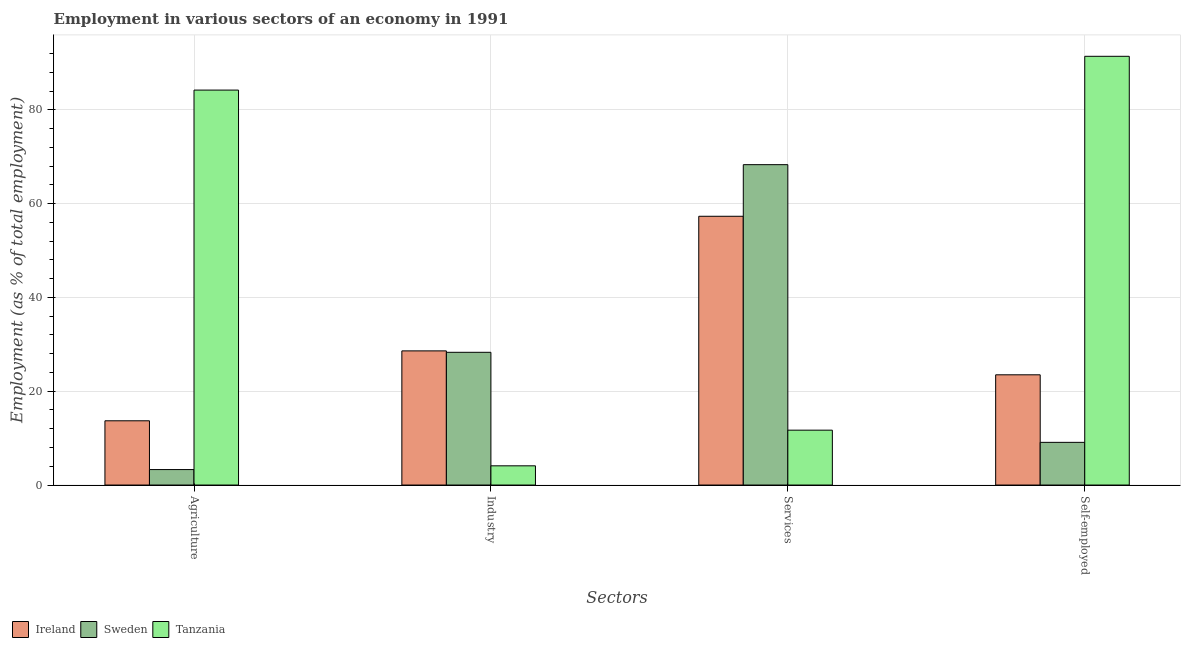How many different coloured bars are there?
Provide a succinct answer. 3. What is the label of the 1st group of bars from the left?
Your answer should be compact. Agriculture. What is the percentage of workers in agriculture in Tanzania?
Offer a very short reply. 84.2. Across all countries, what is the maximum percentage of workers in industry?
Make the answer very short. 28.6. Across all countries, what is the minimum percentage of self employed workers?
Offer a terse response. 9.1. In which country was the percentage of workers in agriculture maximum?
Offer a terse response. Tanzania. In which country was the percentage of workers in services minimum?
Make the answer very short. Tanzania. What is the total percentage of workers in industry in the graph?
Give a very brief answer. 61. What is the difference between the percentage of workers in industry in Tanzania and that in Sweden?
Give a very brief answer. -24.2. What is the difference between the percentage of workers in services in Ireland and the percentage of self employed workers in Tanzania?
Offer a terse response. -34.1. What is the average percentage of workers in services per country?
Offer a terse response. 45.77. What is the difference between the percentage of workers in agriculture and percentage of workers in industry in Tanzania?
Provide a short and direct response. 80.1. In how many countries, is the percentage of workers in agriculture greater than 36 %?
Provide a short and direct response. 1. What is the ratio of the percentage of workers in industry in Sweden to that in Ireland?
Offer a very short reply. 0.99. What is the difference between the highest and the second highest percentage of workers in industry?
Your response must be concise. 0.3. What is the difference between the highest and the lowest percentage of workers in agriculture?
Your answer should be very brief. 80.9. In how many countries, is the percentage of self employed workers greater than the average percentage of self employed workers taken over all countries?
Offer a very short reply. 1. Is it the case that in every country, the sum of the percentage of workers in agriculture and percentage of workers in industry is greater than the sum of percentage of self employed workers and percentage of workers in services?
Ensure brevity in your answer.  No. What does the 1st bar from the left in Agriculture represents?
Make the answer very short. Ireland. Is it the case that in every country, the sum of the percentage of workers in agriculture and percentage of workers in industry is greater than the percentage of workers in services?
Ensure brevity in your answer.  No. What is the difference between two consecutive major ticks on the Y-axis?
Offer a very short reply. 20. Does the graph contain any zero values?
Provide a succinct answer. No. How many legend labels are there?
Your answer should be very brief. 3. What is the title of the graph?
Offer a very short reply. Employment in various sectors of an economy in 1991. What is the label or title of the X-axis?
Make the answer very short. Sectors. What is the label or title of the Y-axis?
Your answer should be very brief. Employment (as % of total employment). What is the Employment (as % of total employment) in Ireland in Agriculture?
Ensure brevity in your answer.  13.7. What is the Employment (as % of total employment) of Sweden in Agriculture?
Make the answer very short. 3.3. What is the Employment (as % of total employment) in Tanzania in Agriculture?
Offer a terse response. 84.2. What is the Employment (as % of total employment) in Ireland in Industry?
Your response must be concise. 28.6. What is the Employment (as % of total employment) of Sweden in Industry?
Keep it short and to the point. 28.3. What is the Employment (as % of total employment) in Tanzania in Industry?
Ensure brevity in your answer.  4.1. What is the Employment (as % of total employment) in Ireland in Services?
Offer a very short reply. 57.3. What is the Employment (as % of total employment) of Sweden in Services?
Your response must be concise. 68.3. What is the Employment (as % of total employment) in Tanzania in Services?
Make the answer very short. 11.7. What is the Employment (as % of total employment) of Ireland in Self-employed?
Your response must be concise. 23.5. What is the Employment (as % of total employment) in Sweden in Self-employed?
Give a very brief answer. 9.1. What is the Employment (as % of total employment) of Tanzania in Self-employed?
Make the answer very short. 91.4. Across all Sectors, what is the maximum Employment (as % of total employment) in Ireland?
Offer a terse response. 57.3. Across all Sectors, what is the maximum Employment (as % of total employment) in Sweden?
Your answer should be very brief. 68.3. Across all Sectors, what is the maximum Employment (as % of total employment) in Tanzania?
Provide a succinct answer. 91.4. Across all Sectors, what is the minimum Employment (as % of total employment) in Ireland?
Keep it short and to the point. 13.7. Across all Sectors, what is the minimum Employment (as % of total employment) of Sweden?
Offer a terse response. 3.3. Across all Sectors, what is the minimum Employment (as % of total employment) of Tanzania?
Provide a short and direct response. 4.1. What is the total Employment (as % of total employment) in Ireland in the graph?
Your answer should be very brief. 123.1. What is the total Employment (as % of total employment) in Sweden in the graph?
Your answer should be very brief. 109. What is the total Employment (as % of total employment) of Tanzania in the graph?
Offer a very short reply. 191.4. What is the difference between the Employment (as % of total employment) of Ireland in Agriculture and that in Industry?
Make the answer very short. -14.9. What is the difference between the Employment (as % of total employment) in Tanzania in Agriculture and that in Industry?
Offer a terse response. 80.1. What is the difference between the Employment (as % of total employment) of Ireland in Agriculture and that in Services?
Your answer should be compact. -43.6. What is the difference between the Employment (as % of total employment) in Sweden in Agriculture and that in Services?
Give a very brief answer. -65. What is the difference between the Employment (as % of total employment) in Tanzania in Agriculture and that in Services?
Your response must be concise. 72.5. What is the difference between the Employment (as % of total employment) in Ireland in Agriculture and that in Self-employed?
Your response must be concise. -9.8. What is the difference between the Employment (as % of total employment) in Ireland in Industry and that in Services?
Keep it short and to the point. -28.7. What is the difference between the Employment (as % of total employment) of Tanzania in Industry and that in Services?
Offer a very short reply. -7.6. What is the difference between the Employment (as % of total employment) in Ireland in Industry and that in Self-employed?
Your response must be concise. 5.1. What is the difference between the Employment (as % of total employment) of Tanzania in Industry and that in Self-employed?
Keep it short and to the point. -87.3. What is the difference between the Employment (as % of total employment) of Ireland in Services and that in Self-employed?
Provide a short and direct response. 33.8. What is the difference between the Employment (as % of total employment) in Sweden in Services and that in Self-employed?
Your answer should be very brief. 59.2. What is the difference between the Employment (as % of total employment) in Tanzania in Services and that in Self-employed?
Offer a terse response. -79.7. What is the difference between the Employment (as % of total employment) in Ireland in Agriculture and the Employment (as % of total employment) in Sweden in Industry?
Your answer should be very brief. -14.6. What is the difference between the Employment (as % of total employment) in Sweden in Agriculture and the Employment (as % of total employment) in Tanzania in Industry?
Offer a very short reply. -0.8. What is the difference between the Employment (as % of total employment) of Ireland in Agriculture and the Employment (as % of total employment) of Sweden in Services?
Keep it short and to the point. -54.6. What is the difference between the Employment (as % of total employment) of Ireland in Agriculture and the Employment (as % of total employment) of Tanzania in Services?
Provide a succinct answer. 2. What is the difference between the Employment (as % of total employment) in Ireland in Agriculture and the Employment (as % of total employment) in Tanzania in Self-employed?
Provide a short and direct response. -77.7. What is the difference between the Employment (as % of total employment) in Sweden in Agriculture and the Employment (as % of total employment) in Tanzania in Self-employed?
Give a very brief answer. -88.1. What is the difference between the Employment (as % of total employment) in Ireland in Industry and the Employment (as % of total employment) in Sweden in Services?
Give a very brief answer. -39.7. What is the difference between the Employment (as % of total employment) in Ireland in Industry and the Employment (as % of total employment) in Tanzania in Self-employed?
Keep it short and to the point. -62.8. What is the difference between the Employment (as % of total employment) in Sweden in Industry and the Employment (as % of total employment) in Tanzania in Self-employed?
Make the answer very short. -63.1. What is the difference between the Employment (as % of total employment) of Ireland in Services and the Employment (as % of total employment) of Sweden in Self-employed?
Your answer should be very brief. 48.2. What is the difference between the Employment (as % of total employment) of Ireland in Services and the Employment (as % of total employment) of Tanzania in Self-employed?
Provide a succinct answer. -34.1. What is the difference between the Employment (as % of total employment) of Sweden in Services and the Employment (as % of total employment) of Tanzania in Self-employed?
Make the answer very short. -23.1. What is the average Employment (as % of total employment) in Ireland per Sectors?
Provide a short and direct response. 30.77. What is the average Employment (as % of total employment) of Sweden per Sectors?
Provide a short and direct response. 27.25. What is the average Employment (as % of total employment) in Tanzania per Sectors?
Provide a succinct answer. 47.85. What is the difference between the Employment (as % of total employment) in Ireland and Employment (as % of total employment) in Tanzania in Agriculture?
Ensure brevity in your answer.  -70.5. What is the difference between the Employment (as % of total employment) in Sweden and Employment (as % of total employment) in Tanzania in Agriculture?
Offer a very short reply. -80.9. What is the difference between the Employment (as % of total employment) in Ireland and Employment (as % of total employment) in Tanzania in Industry?
Give a very brief answer. 24.5. What is the difference between the Employment (as % of total employment) of Sweden and Employment (as % of total employment) of Tanzania in Industry?
Ensure brevity in your answer.  24.2. What is the difference between the Employment (as % of total employment) of Ireland and Employment (as % of total employment) of Tanzania in Services?
Your answer should be compact. 45.6. What is the difference between the Employment (as % of total employment) in Sweden and Employment (as % of total employment) in Tanzania in Services?
Your answer should be very brief. 56.6. What is the difference between the Employment (as % of total employment) in Ireland and Employment (as % of total employment) in Sweden in Self-employed?
Provide a short and direct response. 14.4. What is the difference between the Employment (as % of total employment) of Ireland and Employment (as % of total employment) of Tanzania in Self-employed?
Your response must be concise. -67.9. What is the difference between the Employment (as % of total employment) in Sweden and Employment (as % of total employment) in Tanzania in Self-employed?
Make the answer very short. -82.3. What is the ratio of the Employment (as % of total employment) in Ireland in Agriculture to that in Industry?
Make the answer very short. 0.48. What is the ratio of the Employment (as % of total employment) of Sweden in Agriculture to that in Industry?
Your answer should be very brief. 0.12. What is the ratio of the Employment (as % of total employment) of Tanzania in Agriculture to that in Industry?
Keep it short and to the point. 20.54. What is the ratio of the Employment (as % of total employment) of Ireland in Agriculture to that in Services?
Offer a very short reply. 0.24. What is the ratio of the Employment (as % of total employment) in Sweden in Agriculture to that in Services?
Give a very brief answer. 0.05. What is the ratio of the Employment (as % of total employment) in Tanzania in Agriculture to that in Services?
Your response must be concise. 7.2. What is the ratio of the Employment (as % of total employment) of Ireland in Agriculture to that in Self-employed?
Ensure brevity in your answer.  0.58. What is the ratio of the Employment (as % of total employment) in Sweden in Agriculture to that in Self-employed?
Provide a succinct answer. 0.36. What is the ratio of the Employment (as % of total employment) of Tanzania in Agriculture to that in Self-employed?
Offer a very short reply. 0.92. What is the ratio of the Employment (as % of total employment) in Ireland in Industry to that in Services?
Keep it short and to the point. 0.5. What is the ratio of the Employment (as % of total employment) of Sweden in Industry to that in Services?
Offer a terse response. 0.41. What is the ratio of the Employment (as % of total employment) of Tanzania in Industry to that in Services?
Your answer should be compact. 0.35. What is the ratio of the Employment (as % of total employment) in Ireland in Industry to that in Self-employed?
Provide a short and direct response. 1.22. What is the ratio of the Employment (as % of total employment) in Sweden in Industry to that in Self-employed?
Your answer should be compact. 3.11. What is the ratio of the Employment (as % of total employment) of Tanzania in Industry to that in Self-employed?
Your answer should be very brief. 0.04. What is the ratio of the Employment (as % of total employment) of Ireland in Services to that in Self-employed?
Your response must be concise. 2.44. What is the ratio of the Employment (as % of total employment) in Sweden in Services to that in Self-employed?
Offer a terse response. 7.51. What is the ratio of the Employment (as % of total employment) in Tanzania in Services to that in Self-employed?
Provide a succinct answer. 0.13. What is the difference between the highest and the second highest Employment (as % of total employment) in Ireland?
Make the answer very short. 28.7. What is the difference between the highest and the lowest Employment (as % of total employment) of Ireland?
Your response must be concise. 43.6. What is the difference between the highest and the lowest Employment (as % of total employment) in Tanzania?
Keep it short and to the point. 87.3. 